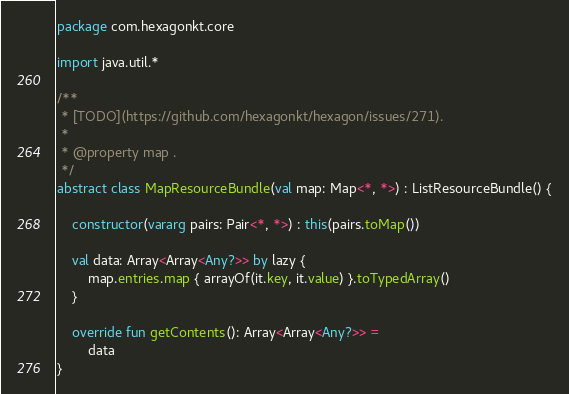<code> <loc_0><loc_0><loc_500><loc_500><_Kotlin_>package com.hexagonkt.core

import java.util.*

/**
 * [TODO](https://github.com/hexagonkt/hexagon/issues/271).
 *
 * @property map .
 */
abstract class MapResourceBundle(val map: Map<*, *>) : ListResourceBundle() {

    constructor(vararg pairs: Pair<*, *>) : this(pairs.toMap())

    val data: Array<Array<Any?>> by lazy {
        map.entries.map { arrayOf(it.key, it.value) }.toTypedArray()
    }

    override fun getContents(): Array<Array<Any?>> =
        data
}
</code> 